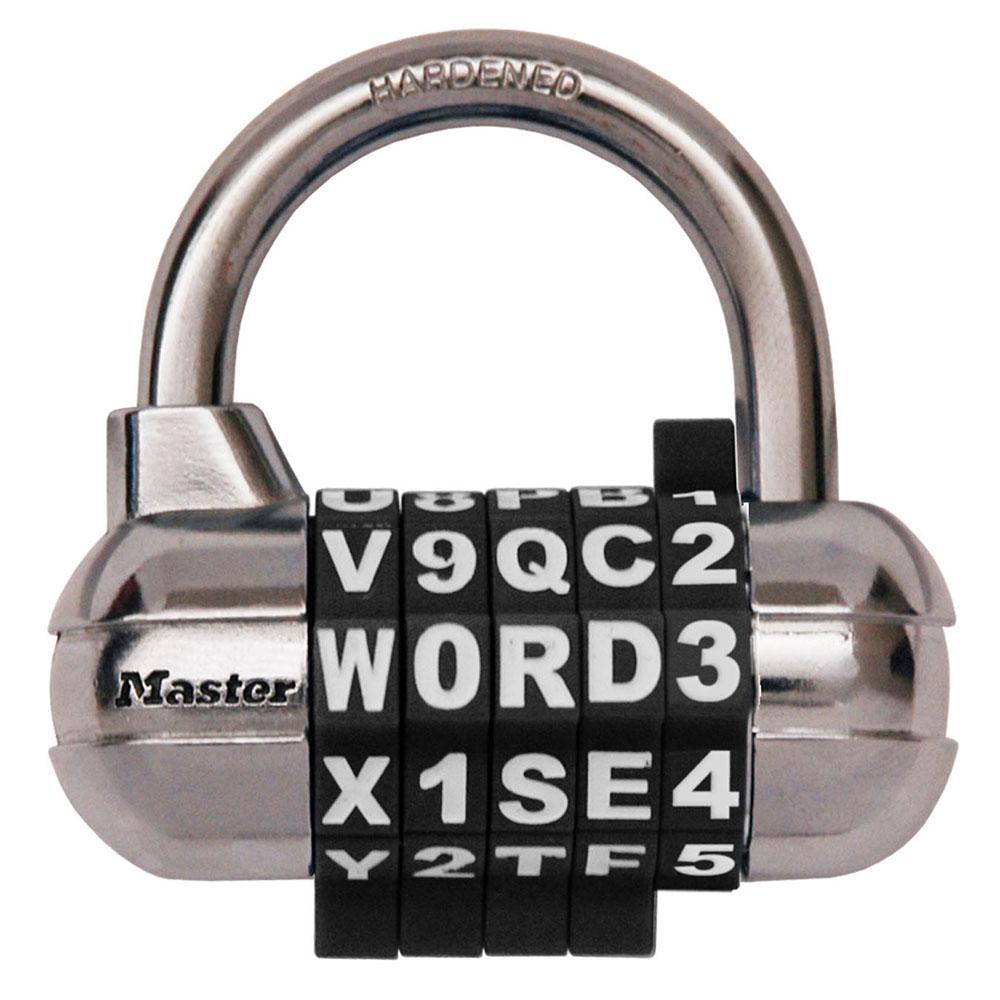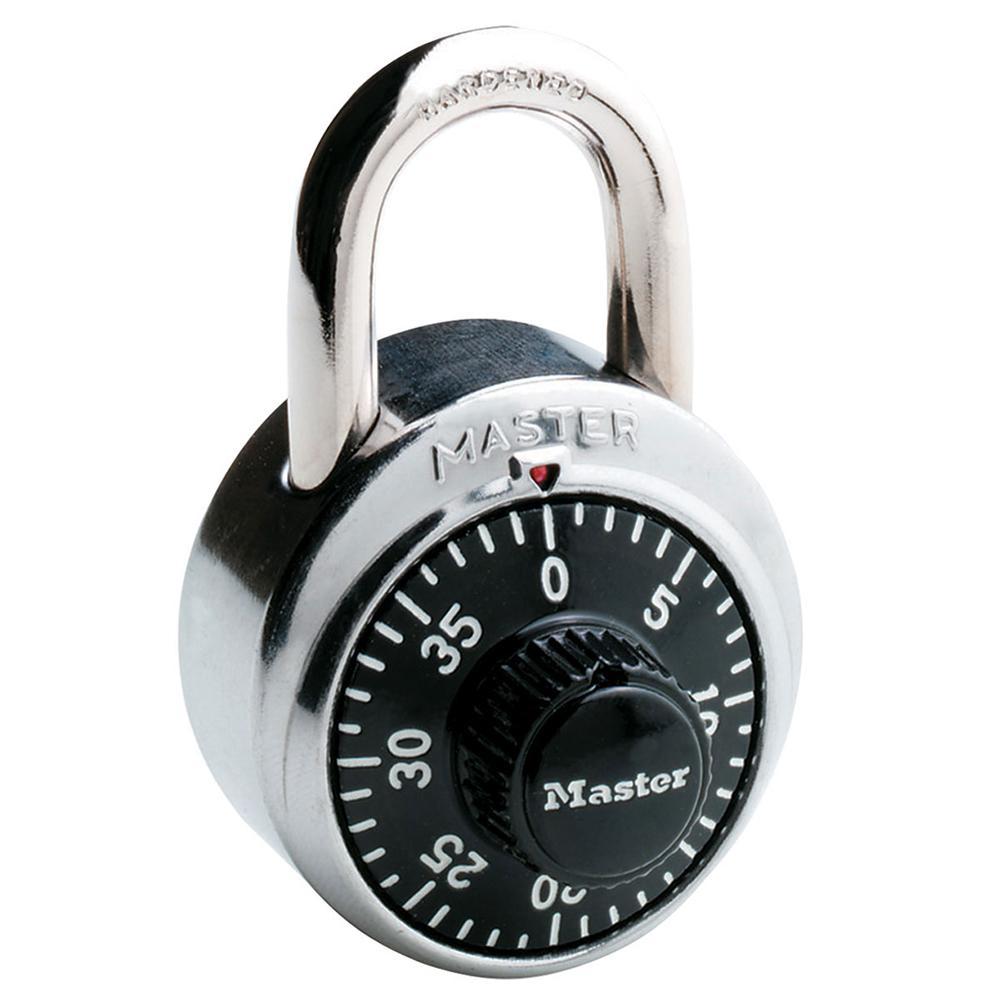The first image is the image on the left, the second image is the image on the right. Considering the images on both sides, is "An image includes a capsule-shaped lock with a combination wheel containing white letters and numbers on black." valid? Answer yes or no. Yes. The first image is the image on the left, the second image is the image on the right. Given the left and right images, does the statement "There are at most 3 padlocks in total." hold true? Answer yes or no. Yes. 